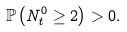<formula> <loc_0><loc_0><loc_500><loc_500>\mathbb { P } \left ( N ^ { 0 } _ { t } \geq 2 \right ) > 0 .</formula> 